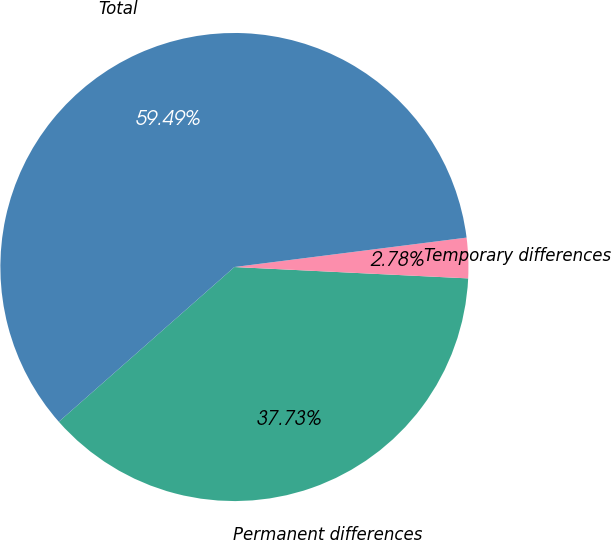Convert chart. <chart><loc_0><loc_0><loc_500><loc_500><pie_chart><fcel>Permanent differences<fcel>Temporary differences<fcel>Total<nl><fcel>37.73%<fcel>2.78%<fcel>59.49%<nl></chart> 